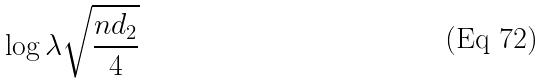<formula> <loc_0><loc_0><loc_500><loc_500>\log \lambda \sqrt { \frac { n d _ { 2 } } { 4 } }</formula> 